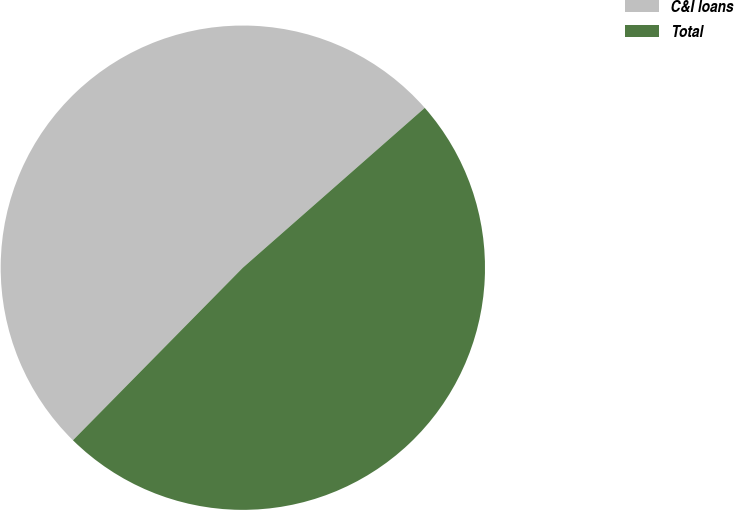<chart> <loc_0><loc_0><loc_500><loc_500><pie_chart><fcel>C&I loans<fcel>Total<nl><fcel>51.15%<fcel>48.85%<nl></chart> 